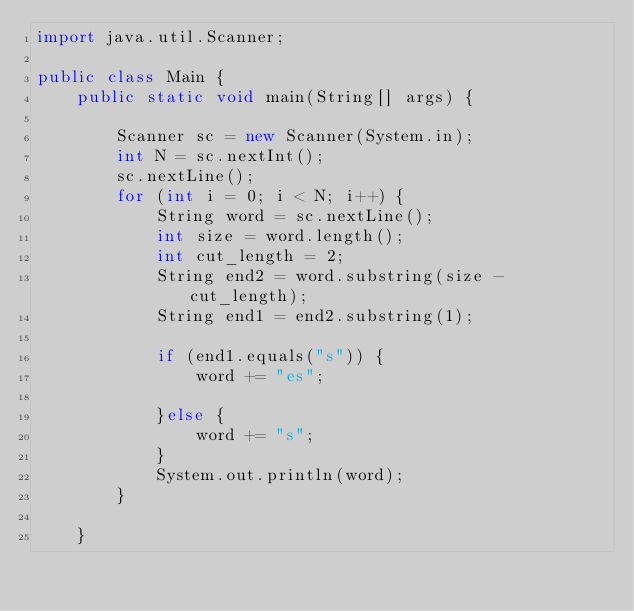<code> <loc_0><loc_0><loc_500><loc_500><_Java_>import java.util.Scanner;

public class Main {
    public static void main(String[] args) {

        Scanner sc = new Scanner(System.in);
        int N = sc.nextInt();
        sc.nextLine();
        for (int i = 0; i < N; i++) {
            String word = sc.nextLine();
            int size = word.length();
            int cut_length = 2;
            String end2 = word.substring(size - cut_length);
            String end1 = end2.substring(1);

            if (end1.equals("s")) {
                word += "es";

            }else {
                word += "s";
            }
            System.out.println(word);
        }

    }</code> 